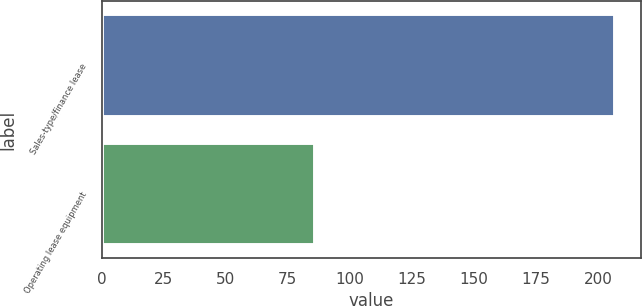Convert chart to OTSL. <chart><loc_0><loc_0><loc_500><loc_500><bar_chart><fcel>Sales-type/finance lease<fcel>Operating lease equipment<nl><fcel>207<fcel>86<nl></chart> 